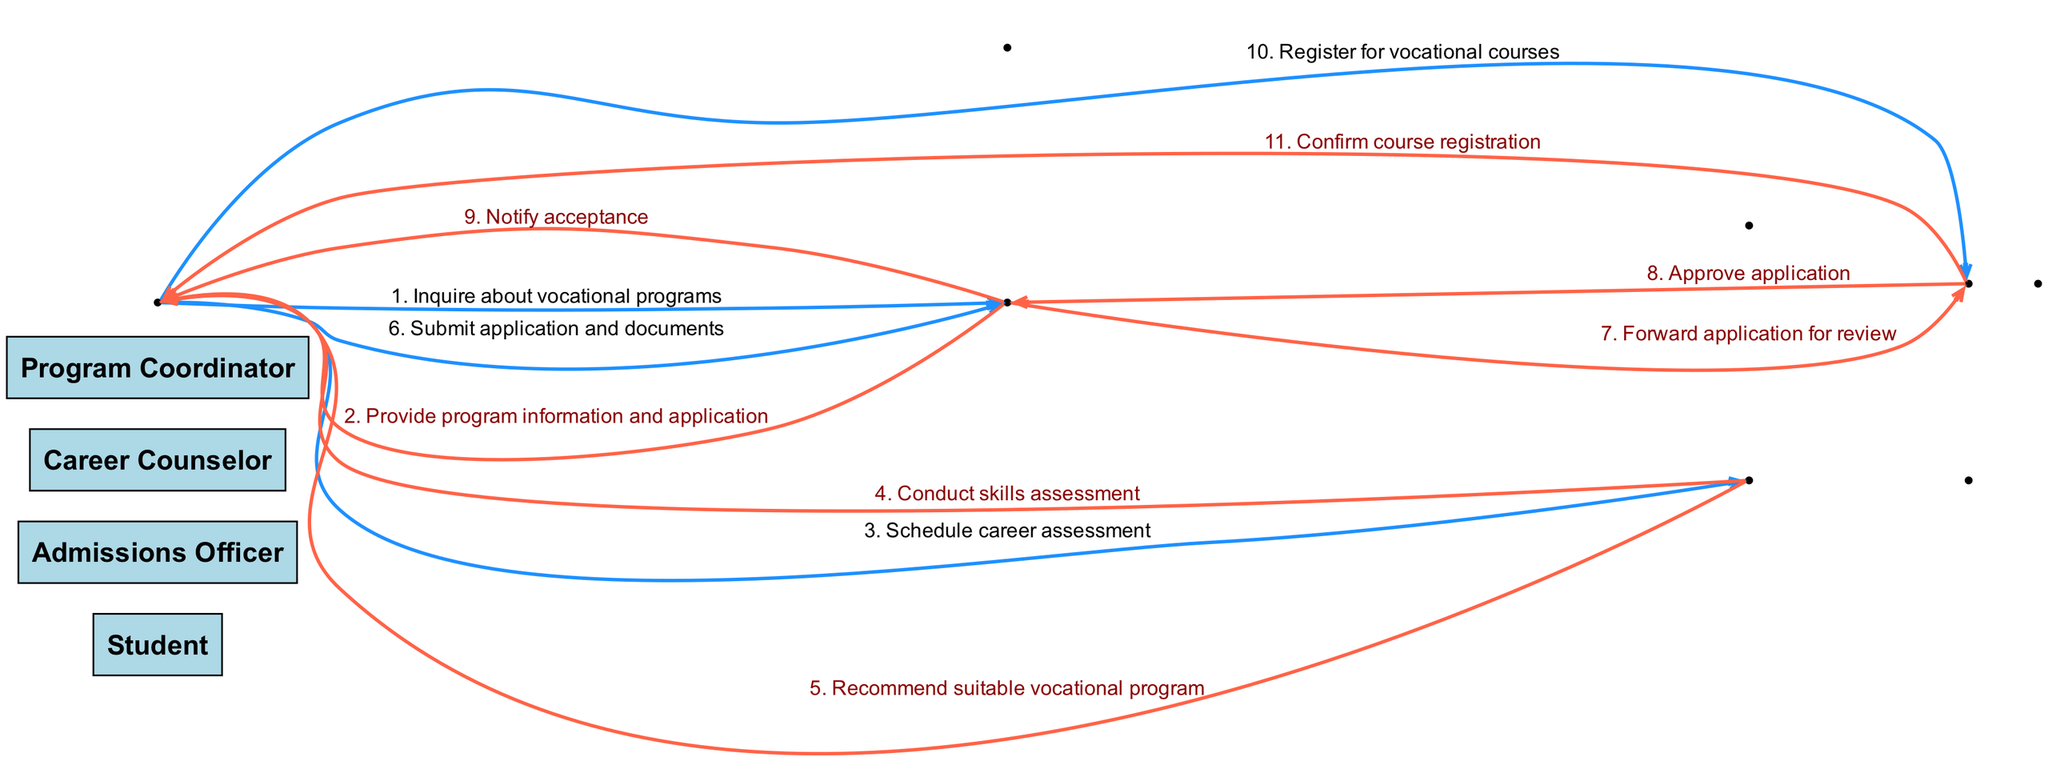What is the first message in the sequence? The first message in the sequence is "Inquire about vocational programs," which is sent from the Student to the Admissions Officer.
Answer: Inquire about vocational programs How many actors are involved in the process? There are four actors involved in the process: Student, Admissions Officer, Career Counselor, and Program Coordinator.
Answer: Four Which actor sends a message to the Program Coordinator? The Admissions Officer sends a message to the Program Coordinator with the message "Forward application for review."
Answer: Admissions Officer What does the Career Counselor recommend to the Student? The Career Counselor recommends a suitable vocational program after conducting the skills assessment.
Answer: Suitable vocational program What is the last action taken by the Student in this sequence? The last action taken by the Student is to register for vocational courses.
Answer: Register for vocational courses How many messages are sent from the Student? There are five messages sent from the Student throughout the enrollment process.
Answer: Five Which two actors are involved in notifying acceptance? The actors involved in notifying acceptance are the Admissions Officer and the Student.
Answer: Admissions Officer and Student In which step does the application get approved? The application gets approved in the step where the Program Coordinator sends "Approve application" back to the Admissions Officer.
Answer: Approve application 